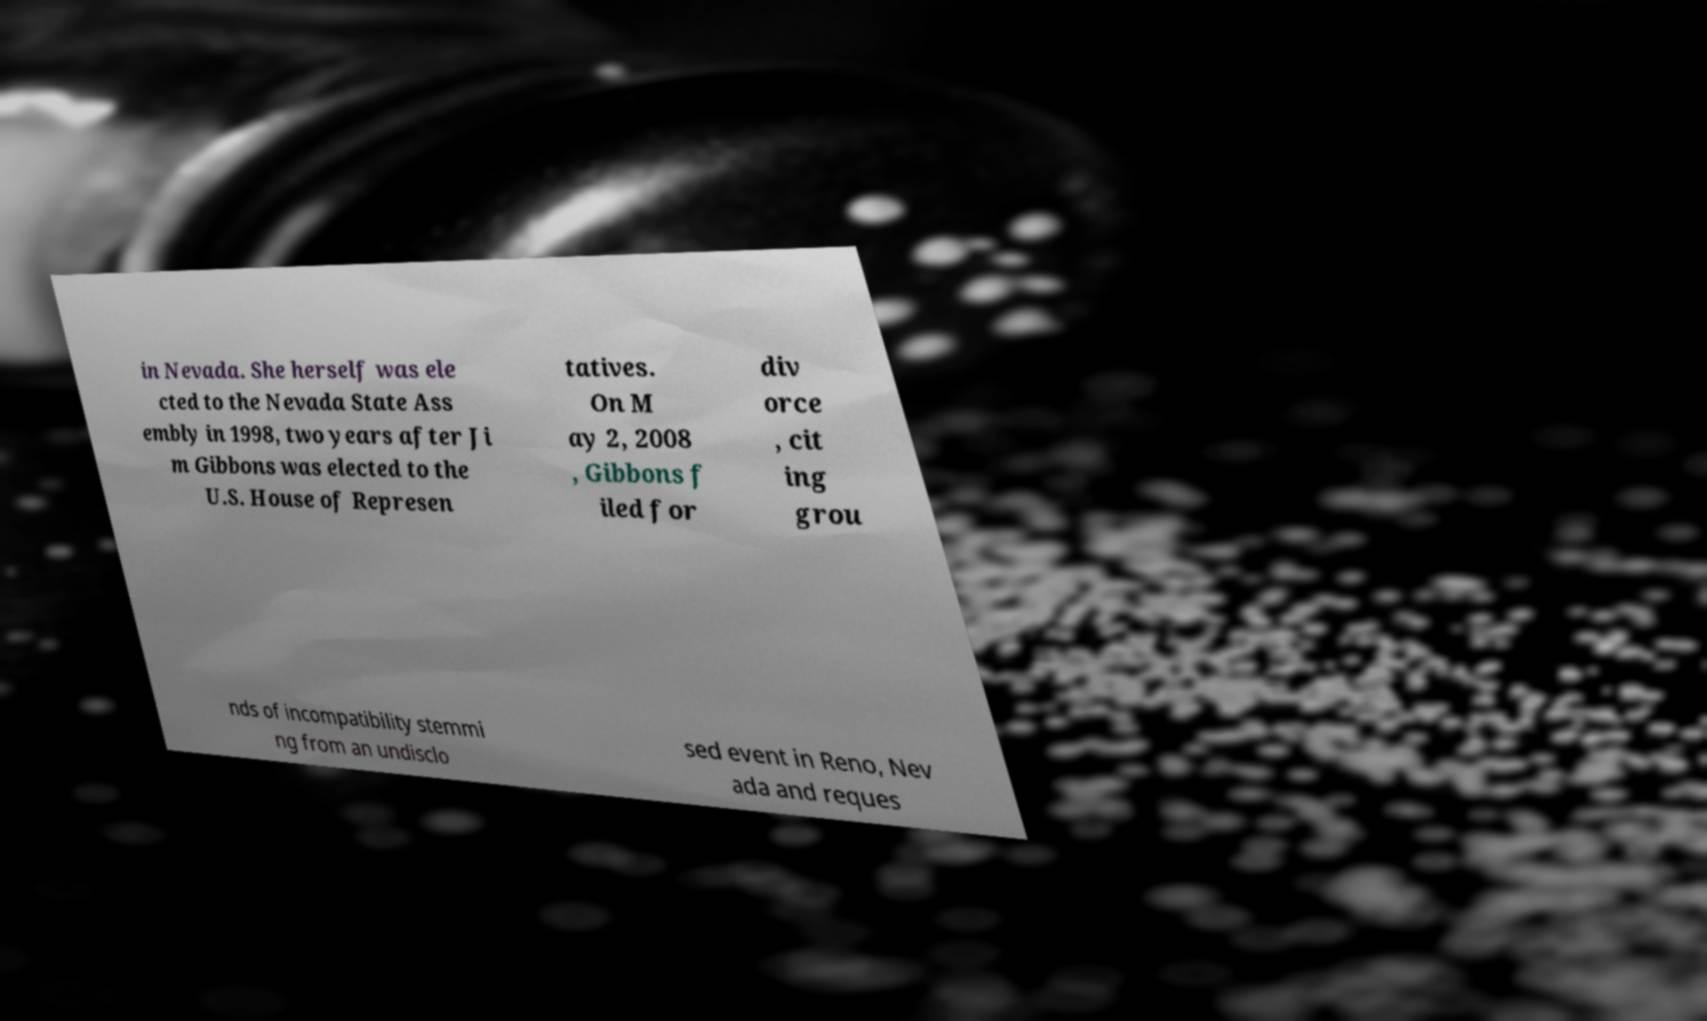Please identify and transcribe the text found in this image. in Nevada. She herself was ele cted to the Nevada State Ass embly in 1998, two years after Ji m Gibbons was elected to the U.S. House of Represen tatives. On M ay 2, 2008 , Gibbons f iled for div orce , cit ing grou nds of incompatibility stemmi ng from an undisclo sed event in Reno, Nev ada and reques 